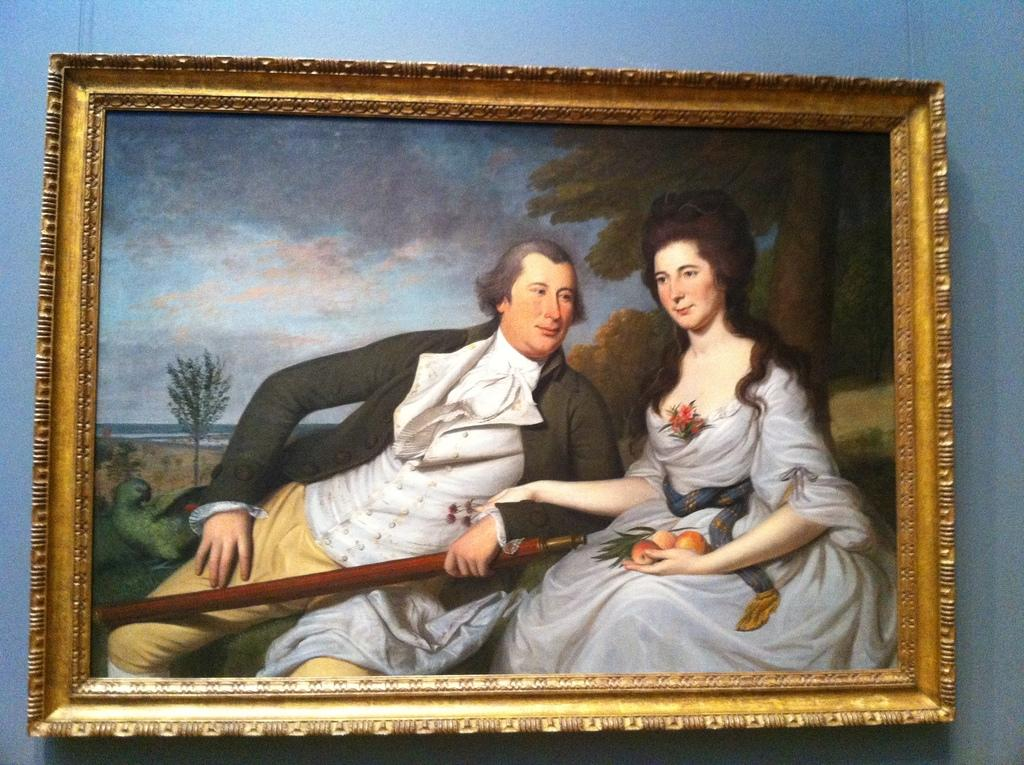What is hanging on the wall in the image? There is a photo frame on the wall in the image. What is depicted in the photo frame? The photo frame contains an image of a man holding a stick and an image of a lady holding some fruits. Are there any animals in the photo frame? Yes, there is a bird in the photo frame. What else can be seen in the photo frame? There are plants, trees, and the sky visible in the photo frame. What scent can be detected coming from the dog in the image? There is no dog present in the image, so no scent can be detected. How is your aunt related to the man in the photo frame? The provided facts do not mention any relation to an aunt, so we cannot determine how she might be related to the man in the photo frame. 